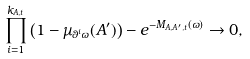<formula> <loc_0><loc_0><loc_500><loc_500>\prod _ { i = 1 } ^ { k _ { A , t } } \left ( 1 - \mu _ { \theta ^ { i } \omega } ( A ^ { \prime } ) \right ) - e ^ { - M _ { A , A ^ { \prime } , t } ( \omega ) } \to 0 ,</formula> 